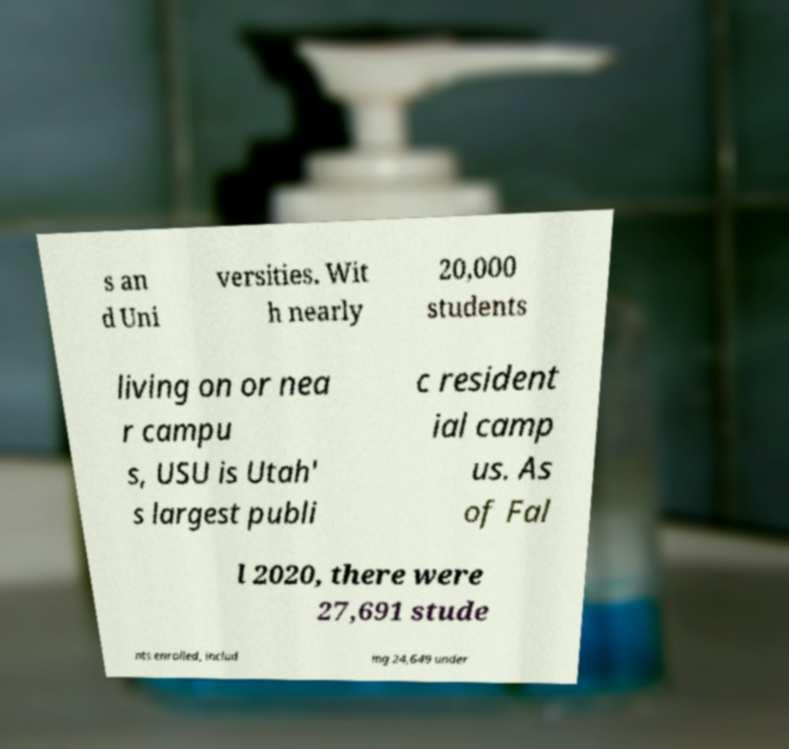Could you assist in decoding the text presented in this image and type it out clearly? s an d Uni versities. Wit h nearly 20,000 students living on or nea r campu s, USU is Utah' s largest publi c resident ial camp us. As of Fal l 2020, there were 27,691 stude nts enrolled, includ ing 24,649 under 